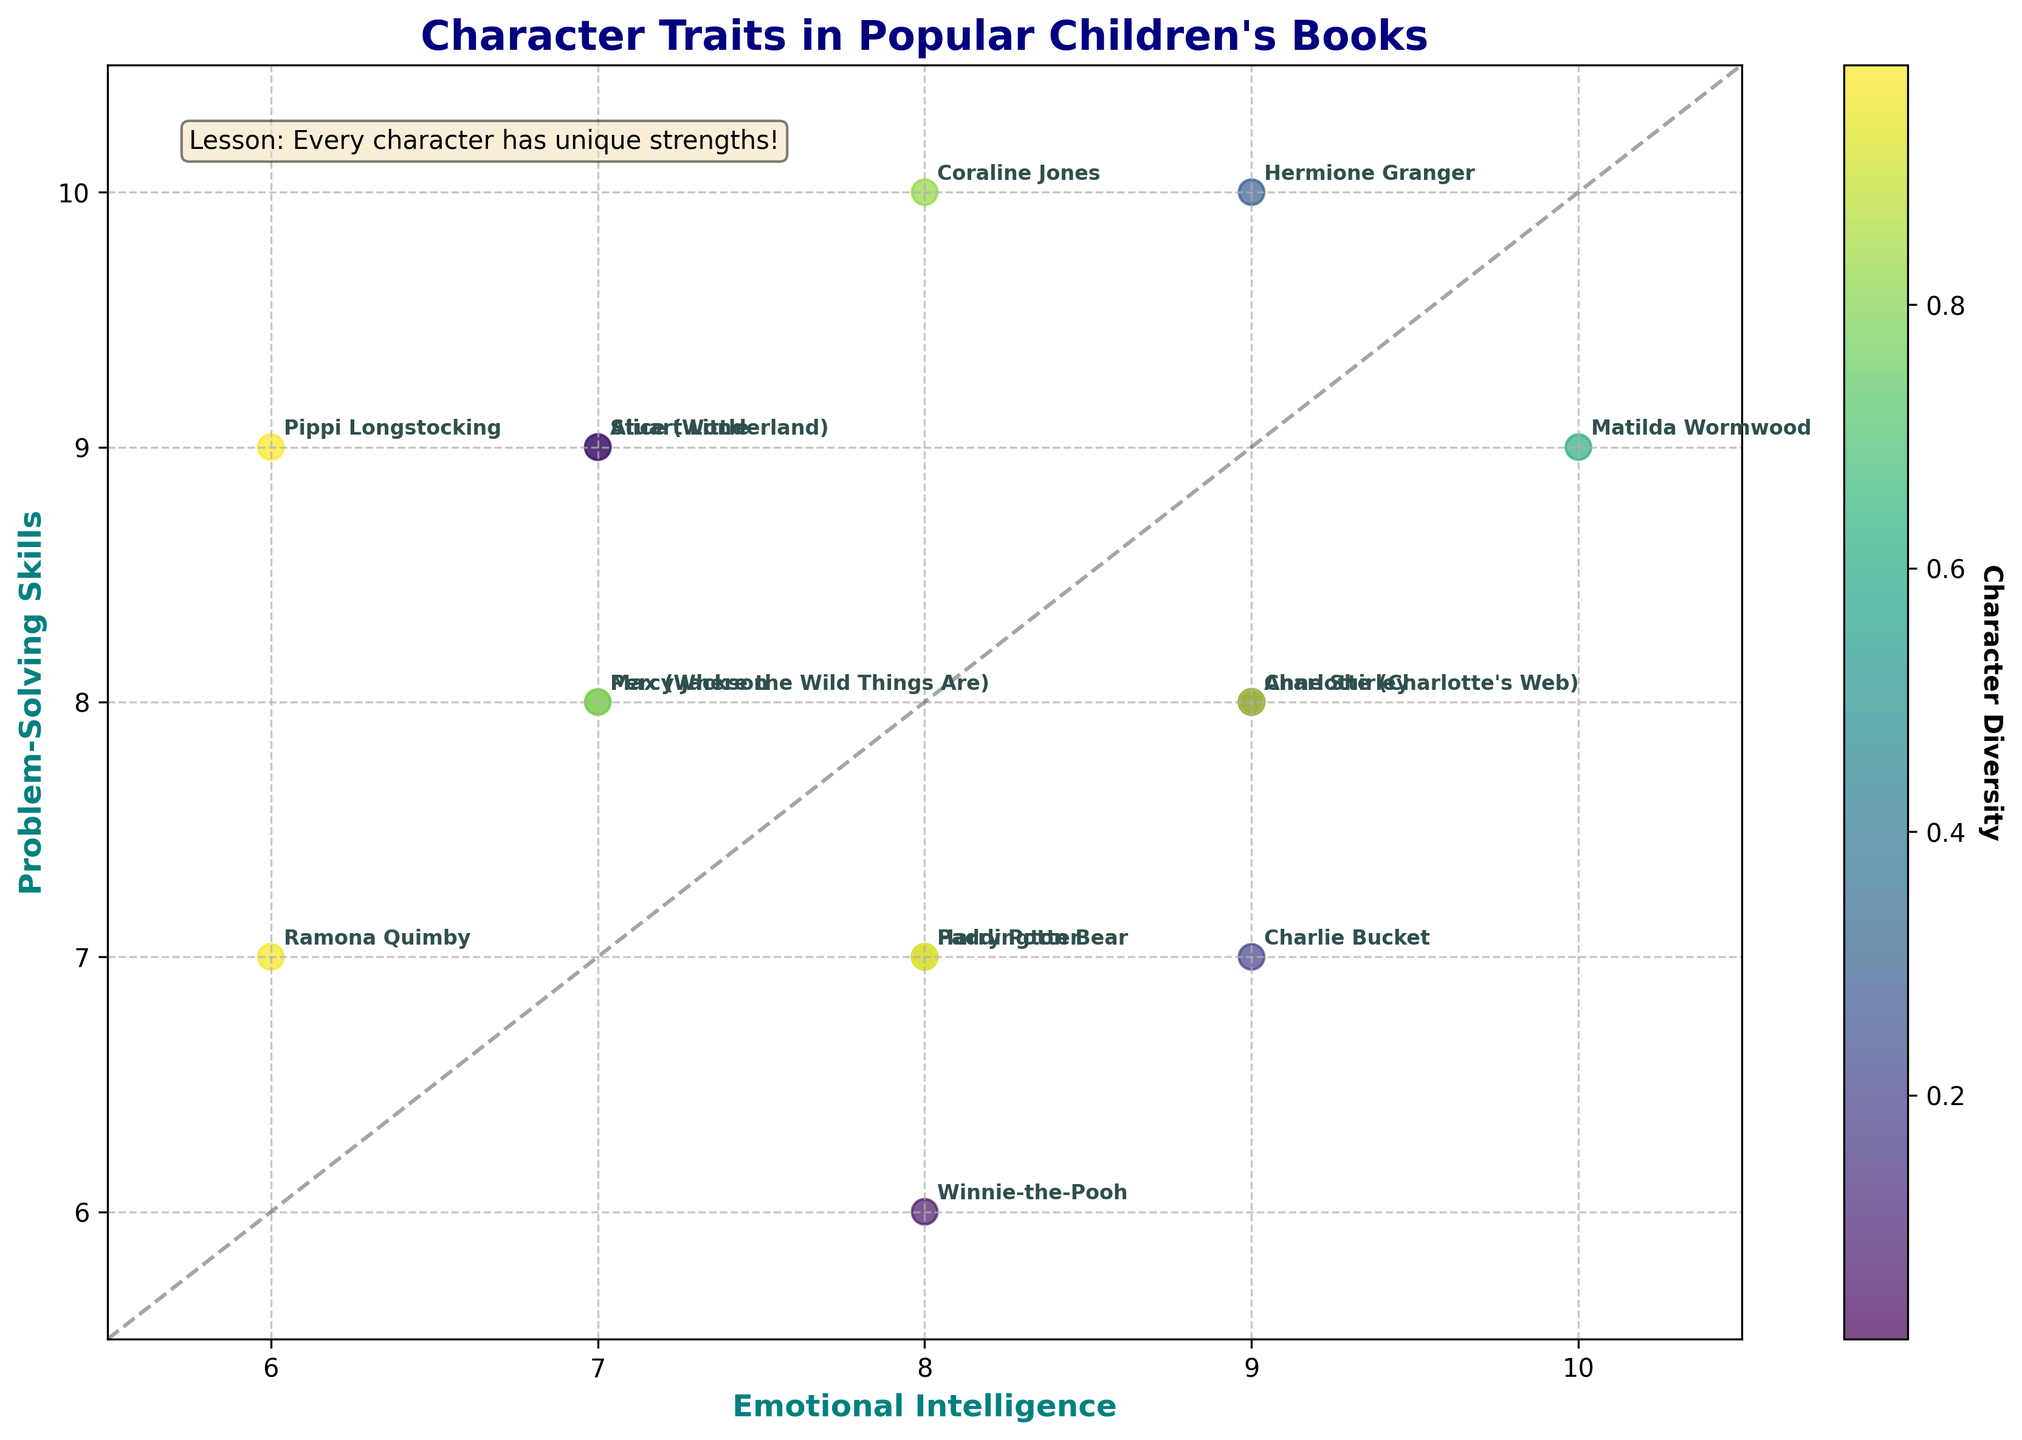What's the title of the plot? The title of the plot is located at the top center and clearly states the main topic of the visualization.
Answer: Character Traits in Popular Children's Books What do the x and y axes represent? The x and y axes represent 'Emotional Intelligence' and 'Problem-Solving Skills' respectively, which label the horizontal and vertical scales of the plot.
Answer: Emotional Intelligence and Problem-Solving Skills Which character has the highest emotional intelligence? A character with the highest score on the x-axis has the highest emotional intelligence, represented by a plotted point farthest to the right. This point is at (10, 9).
Answer: Matilda Wormwood How many characters have an emotional intelligence score of 8? Locate the x value of 8 on the x-axis and count the number of points vertically aligned with this score. Points for Harry Potter, Winnie-the-Pooh, Paddington Bear, and Coraline Jones are seen here.
Answer: Four Who has equal scores in both emotional intelligence and problem-solving skills? Look for points directly on the diagonal line (where x equals y) to identify characters with equal scores.
Answer: None Among characters with high problem-solving skills (9 or above), who has the lowest emotional intelligence? Focus on points with a y value of 9 or above. The one with the lowest x value within this range is Pippi Longstocking at (6, 9).
Answer: Pippi Longstocking Which character is furthest from the average scores of all characters? Calculate the average of the x and y values (find the centroid point) and see which character is furthest—likely one in the furthest-most plotted points. The average for Emotional Intelligence is 8, and for Problem-Solving Skills is approximately 8.13. Compare this with all characters, and Pippi Longstocking at (6, 9) is furthest by Euclidean distance.
Answer: Pippi Longstocking What message does the text box in the plot convey? The text box usually contains an important takeaway or lesson, placed prominently for viewers to read.
Answer: Lesson: Every character has unique strengths! 